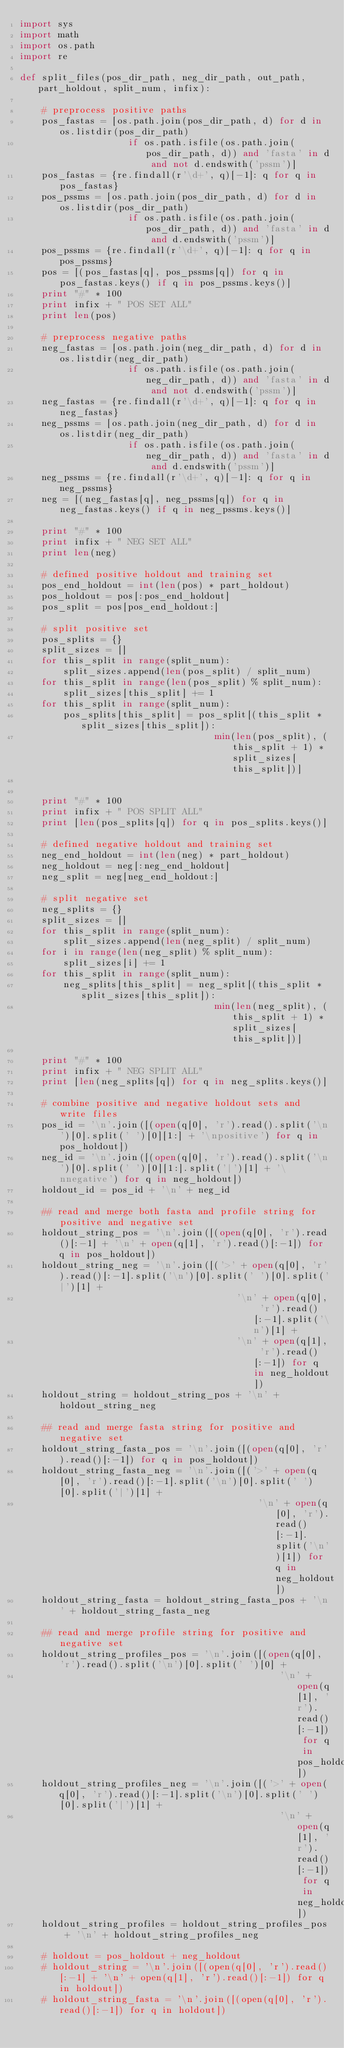<code> <loc_0><loc_0><loc_500><loc_500><_Python_>import sys
import math
import os.path
import re

def split_files(pos_dir_path, neg_dir_path, out_path, part_holdout, split_num, infix):

	# preprocess positive paths
	pos_fastas = [os.path.join(pos_dir_path, d) for d in os.listdir(pos_dir_path) 
					if os.path.isfile(os.path.join(pos_dir_path, d)) and 'fasta' in d and not d.endswith('pssm')]
	pos_fastas = {re.findall(r'\d+', q)[-1]: q for q in pos_fastas}
	pos_pssms = [os.path.join(pos_dir_path, d) for d in os.listdir(pos_dir_path) 
					if os.path.isfile(os.path.join(pos_dir_path, d)) and 'fasta' in d and d.endswith('pssm')]
	pos_pssms = {re.findall(r'\d+', q)[-1]: q for q in pos_pssms}
	pos = [(pos_fastas[q], pos_pssms[q]) for q in pos_fastas.keys() if q in pos_pssms.keys()]
	print "#" * 100
	print infix + " POS SET ALL"
	print len(pos)

	# preprocess negative paths
	neg_fastas = [os.path.join(neg_dir_path, d) for d in os.listdir(neg_dir_path) 
					if os.path.isfile(os.path.join(neg_dir_path, d)) and 'fasta' in d and not d.endswith('pssm')]
	neg_fastas = {re.findall(r'\d+', q)[-1]: q for q in neg_fastas}
	neg_pssms = [os.path.join(neg_dir_path, d) for d in os.listdir(neg_dir_path) 
					if os.path.isfile(os.path.join(neg_dir_path, d)) and 'fasta' in d and d.endswith('pssm')]
	neg_pssms = {re.findall(r'\d+', q)[-1]: q for q in neg_pssms}
	neg = [(neg_fastas[q], neg_pssms[q]) for q in neg_fastas.keys() if q in neg_pssms.keys()]

	print "#" * 100
	print infix + " NEG SET ALL"
	print len(neg)

	# defined positive holdout and training set
	pos_end_holdout = int(len(pos) * part_holdout)
	pos_holdout = pos[:pos_end_holdout]
	pos_split = pos[pos_end_holdout:]

	# split positive set
	pos_splits = {}
	split_sizes = []
	for this_split in range(split_num):
		split_sizes.append(len(pos_split) / split_num)
	for this_split in range(len(pos_split) % split_num):
		split_sizes[this_split] += 1
	for this_split in range(split_num):
		pos_splits[this_split] = pos_split[(this_split * split_sizes[this_split]):
									min(len(pos_split), (this_split + 1) * split_sizes[this_split])]


	print "#" * 100
	print infix + " POS SPLIT ALL"
	print [len(pos_splits[q]) for q in pos_splits.keys()]

	# defined negative holdout and training set
	neg_end_holdout = int(len(neg) * part_holdout)
	neg_holdout = neg[:neg_end_holdout]
	neg_split = neg[neg_end_holdout:]

	# split negative set
	neg_splits = {}
	split_sizes = []
	for this_split in range(split_num):
		split_sizes.append(len(neg_split) / split_num)
	for i in range(len(neg_split) % split_num):
		split_sizes[i] += 1
	for this_split in range(split_num):
		neg_splits[this_split] = neg_split[(this_split * split_sizes[this_split]):
									min(len(neg_split), (this_split + 1) * split_sizes[this_split])]

	print "#" * 100
	print infix + " NEG SPLIT ALL"
	print [len(neg_splits[q]) for q in neg_splits.keys()]

	# combine positive and negative holdout sets and write files
	pos_id = '\n'.join([(open(q[0], 'r').read().split('\n')[0].split(' ')[0][1:] + '\npositive') for q in pos_holdout])
	neg_id = '\n'.join([(open(q[0], 'r').read().split('\n')[0].split(' ')[0][1:].split('|')[1] + '\nnegative') for q in neg_holdout])
	holdout_id = pos_id + '\n' + neg_id

	## read and merge both fasta and profile string for positive and negative set
	holdout_string_pos = '\n'.join([(open(q[0], 'r').read()[:-1] + '\n' + open(q[1], 'r').read()[:-1]) for q in pos_holdout])
	holdout_string_neg = '\n'.join([('>' + open(q[0], 'r').read()[:-1].split('\n')[0].split(' ')[0].split('|')[1] + 
										'\n' + open(q[0], 'r').read()[:-1].split('\n')[1] + 
										'\n' + open(q[1], 'r').read()[:-1]) for q in neg_holdout])
	holdout_string = holdout_string_pos + '\n' + holdout_string_neg

	## read and merge fasta string for positive and negative set
	holdout_string_fasta_pos = '\n'.join([(open(q[0], 'r').read()[:-1]) for q in pos_holdout])
	holdout_string_fasta_neg = '\n'.join([('>' + open(q[0], 'r').read()[:-1].split('\n')[0].split(' ')[0].split('|')[1] + 
											'\n' + open(q[0], 'r').read()[:-1].split('\n')[1]) for q in neg_holdout])
	holdout_string_fasta = holdout_string_fasta_pos + '\n' + holdout_string_fasta_neg

	## read and merge profile string for positive and negative set
	holdout_string_profiles_pos = '\n'.join([(open(q[0], 'r').read().split('\n')[0].split(' ')[0] + 
												'\n' +open(q[1], 'r').read()[:-1]) for q in pos_holdout])
	holdout_string_profiles_neg = '\n'.join([('>' + open(q[0], 'r').read()[:-1].split('\n')[0].split(' ')[0].split('|')[1] + 
												'\n' + open(q[1], 'r').read()[:-1]) for q in neg_holdout])
	holdout_string_profiles = holdout_string_profiles_pos + '\n' + holdout_string_profiles_neg

	# holdout = pos_holdout + neg_holdout
	# holdout_string = '\n'.join([(open(q[0], 'r').read()[:-1] + '\n' + open(q[1], 'r').read()[:-1]) for q in holdout])
	# holdout_string_fasta = '\n'.join([(open(q[0], 'r').read()[:-1]) for q in holdout])</code> 